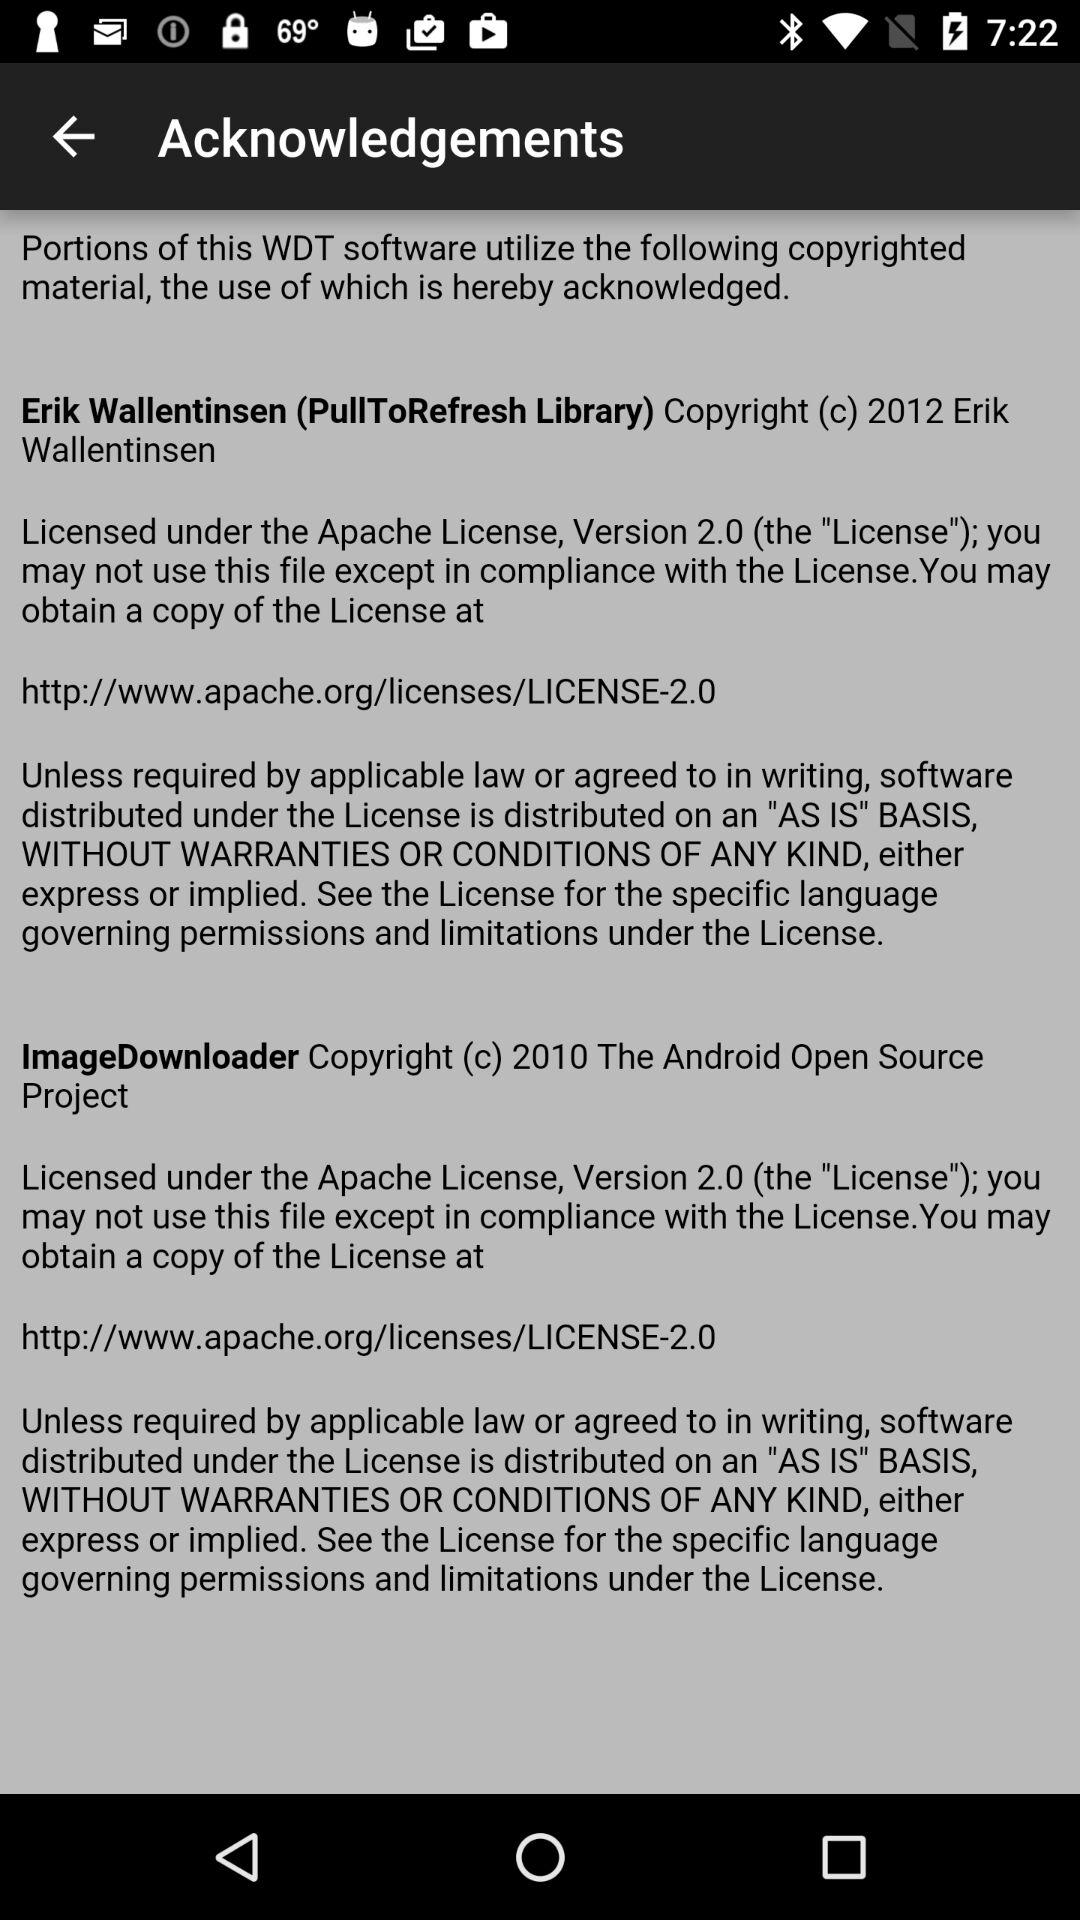How many licenses are mentioned in the acknowledgements section?
Answer the question using a single word or phrase. 2 